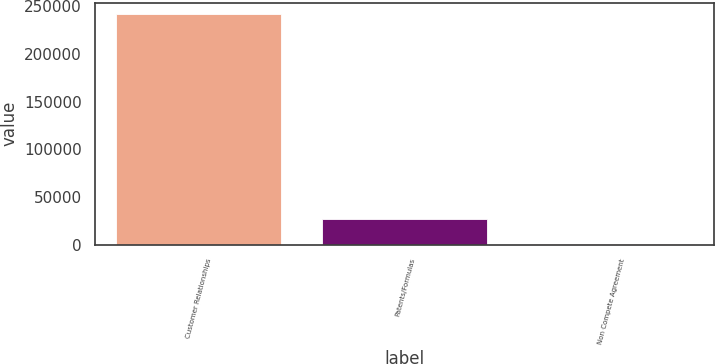<chart> <loc_0><loc_0><loc_500><loc_500><bar_chart><fcel>Customer Relationships<fcel>Patents/Formulas<fcel>Non Compete Agreement<nl><fcel>241640<fcel>27370<fcel>1143<nl></chart> 